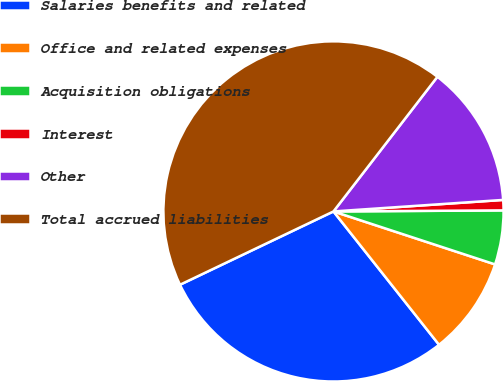Convert chart. <chart><loc_0><loc_0><loc_500><loc_500><pie_chart><fcel>Salaries benefits and related<fcel>Office and related expenses<fcel>Acquisition obligations<fcel>Interest<fcel>Other<fcel>Total accrued liabilities<nl><fcel>28.57%<fcel>9.3%<fcel>5.14%<fcel>0.98%<fcel>13.46%<fcel>42.56%<nl></chart> 